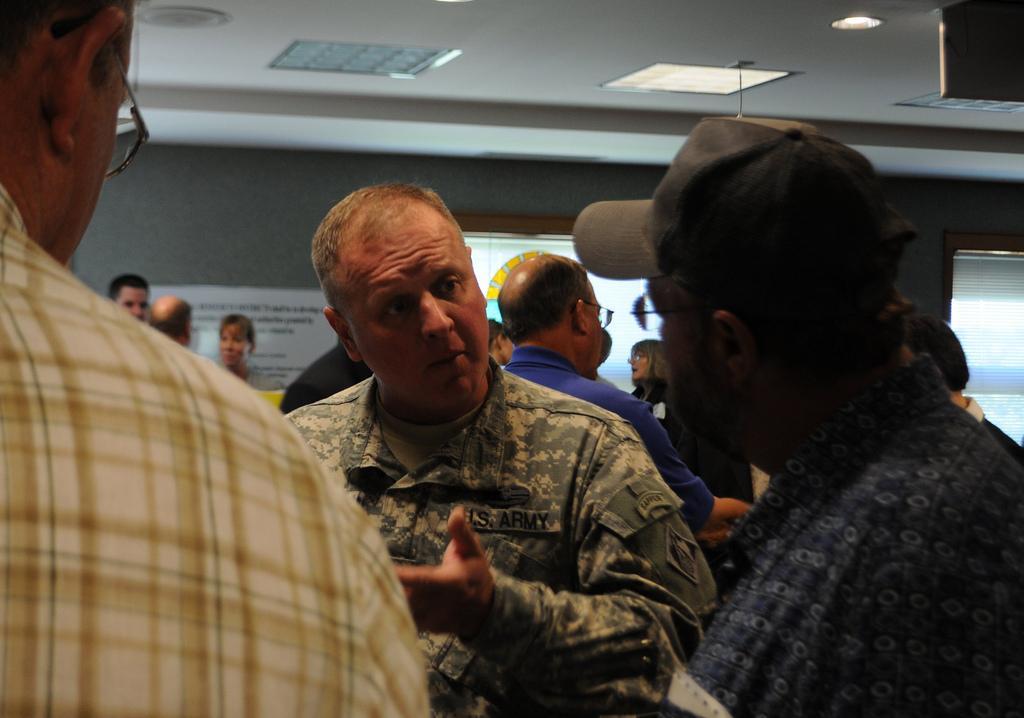Please provide a concise description of this image. In this picture, there are three people in the center. A person in the middle is wearing an uniform. Towards the right, there is another person wearing blue shirt and black cap. Towards the left, there is a man wearing yellow check shirt. In the background, there are people. On the top, there is a ceiling with lights. 